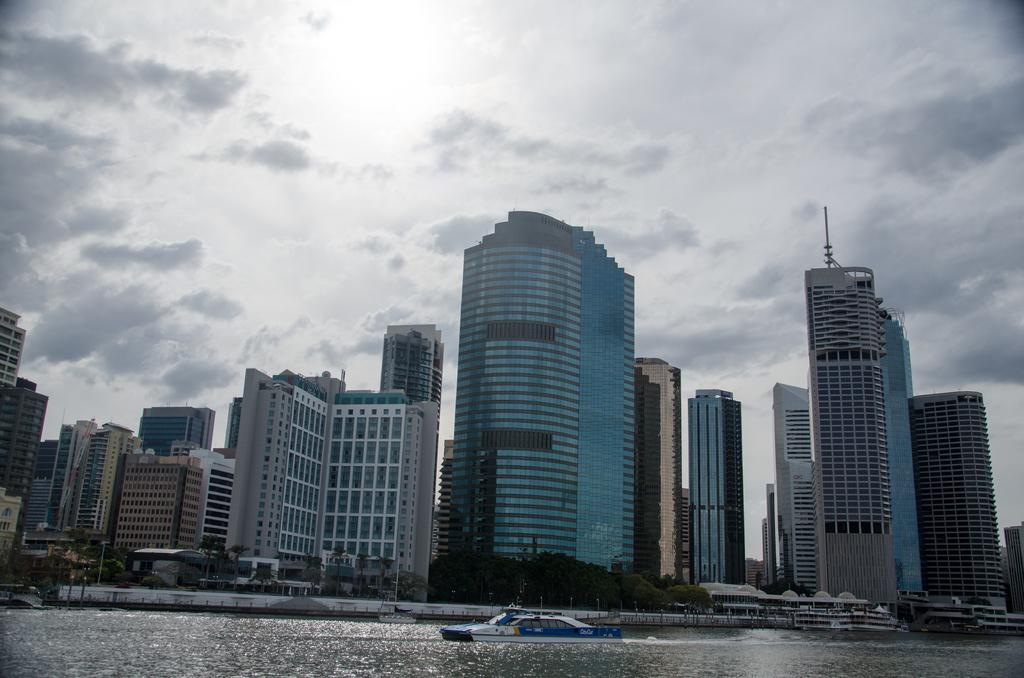What is the main subject of the image? The main subject of the image is a boat. Where is the boat located? The boat is on the water. What other objects or structures can be seen in the image? There are trees and buildings visible in the image. What can be seen in the background of the image? The sky is visible in the background of the image. What type of iron is being used to cook lunch in the image? There is no iron or lunch being cooked in the image; it features a boat on the water with trees, buildings, and a visible sky in the background. 